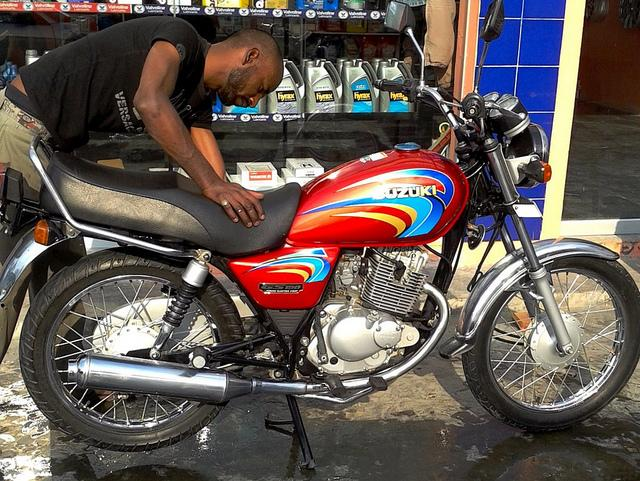What company makes the vehicle?

Choices:
A) ford
B) suzuki
C) tesla
D) general motors suzuki 